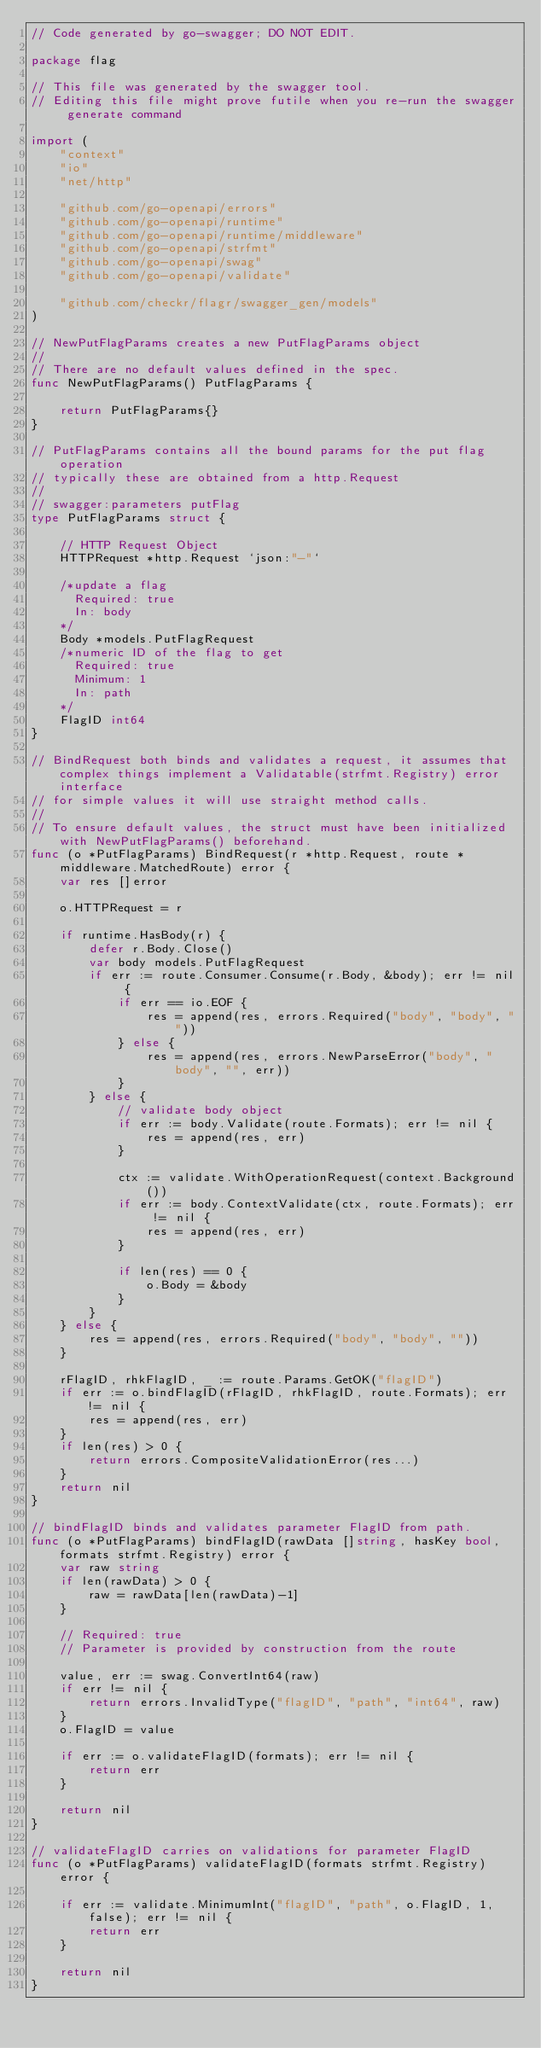Convert code to text. <code><loc_0><loc_0><loc_500><loc_500><_Go_>// Code generated by go-swagger; DO NOT EDIT.

package flag

// This file was generated by the swagger tool.
// Editing this file might prove futile when you re-run the swagger generate command

import (
	"context"
	"io"
	"net/http"

	"github.com/go-openapi/errors"
	"github.com/go-openapi/runtime"
	"github.com/go-openapi/runtime/middleware"
	"github.com/go-openapi/strfmt"
	"github.com/go-openapi/swag"
	"github.com/go-openapi/validate"

	"github.com/checkr/flagr/swagger_gen/models"
)

// NewPutFlagParams creates a new PutFlagParams object
//
// There are no default values defined in the spec.
func NewPutFlagParams() PutFlagParams {

	return PutFlagParams{}
}

// PutFlagParams contains all the bound params for the put flag operation
// typically these are obtained from a http.Request
//
// swagger:parameters putFlag
type PutFlagParams struct {

	// HTTP Request Object
	HTTPRequest *http.Request `json:"-"`

	/*update a flag
	  Required: true
	  In: body
	*/
	Body *models.PutFlagRequest
	/*numeric ID of the flag to get
	  Required: true
	  Minimum: 1
	  In: path
	*/
	FlagID int64
}

// BindRequest both binds and validates a request, it assumes that complex things implement a Validatable(strfmt.Registry) error interface
// for simple values it will use straight method calls.
//
// To ensure default values, the struct must have been initialized with NewPutFlagParams() beforehand.
func (o *PutFlagParams) BindRequest(r *http.Request, route *middleware.MatchedRoute) error {
	var res []error

	o.HTTPRequest = r

	if runtime.HasBody(r) {
		defer r.Body.Close()
		var body models.PutFlagRequest
		if err := route.Consumer.Consume(r.Body, &body); err != nil {
			if err == io.EOF {
				res = append(res, errors.Required("body", "body", ""))
			} else {
				res = append(res, errors.NewParseError("body", "body", "", err))
			}
		} else {
			// validate body object
			if err := body.Validate(route.Formats); err != nil {
				res = append(res, err)
			}

			ctx := validate.WithOperationRequest(context.Background())
			if err := body.ContextValidate(ctx, route.Formats); err != nil {
				res = append(res, err)
			}

			if len(res) == 0 {
				o.Body = &body
			}
		}
	} else {
		res = append(res, errors.Required("body", "body", ""))
	}

	rFlagID, rhkFlagID, _ := route.Params.GetOK("flagID")
	if err := o.bindFlagID(rFlagID, rhkFlagID, route.Formats); err != nil {
		res = append(res, err)
	}
	if len(res) > 0 {
		return errors.CompositeValidationError(res...)
	}
	return nil
}

// bindFlagID binds and validates parameter FlagID from path.
func (o *PutFlagParams) bindFlagID(rawData []string, hasKey bool, formats strfmt.Registry) error {
	var raw string
	if len(rawData) > 0 {
		raw = rawData[len(rawData)-1]
	}

	// Required: true
	// Parameter is provided by construction from the route

	value, err := swag.ConvertInt64(raw)
	if err != nil {
		return errors.InvalidType("flagID", "path", "int64", raw)
	}
	o.FlagID = value

	if err := o.validateFlagID(formats); err != nil {
		return err
	}

	return nil
}

// validateFlagID carries on validations for parameter FlagID
func (o *PutFlagParams) validateFlagID(formats strfmt.Registry) error {

	if err := validate.MinimumInt("flagID", "path", o.FlagID, 1, false); err != nil {
		return err
	}

	return nil
}
</code> 